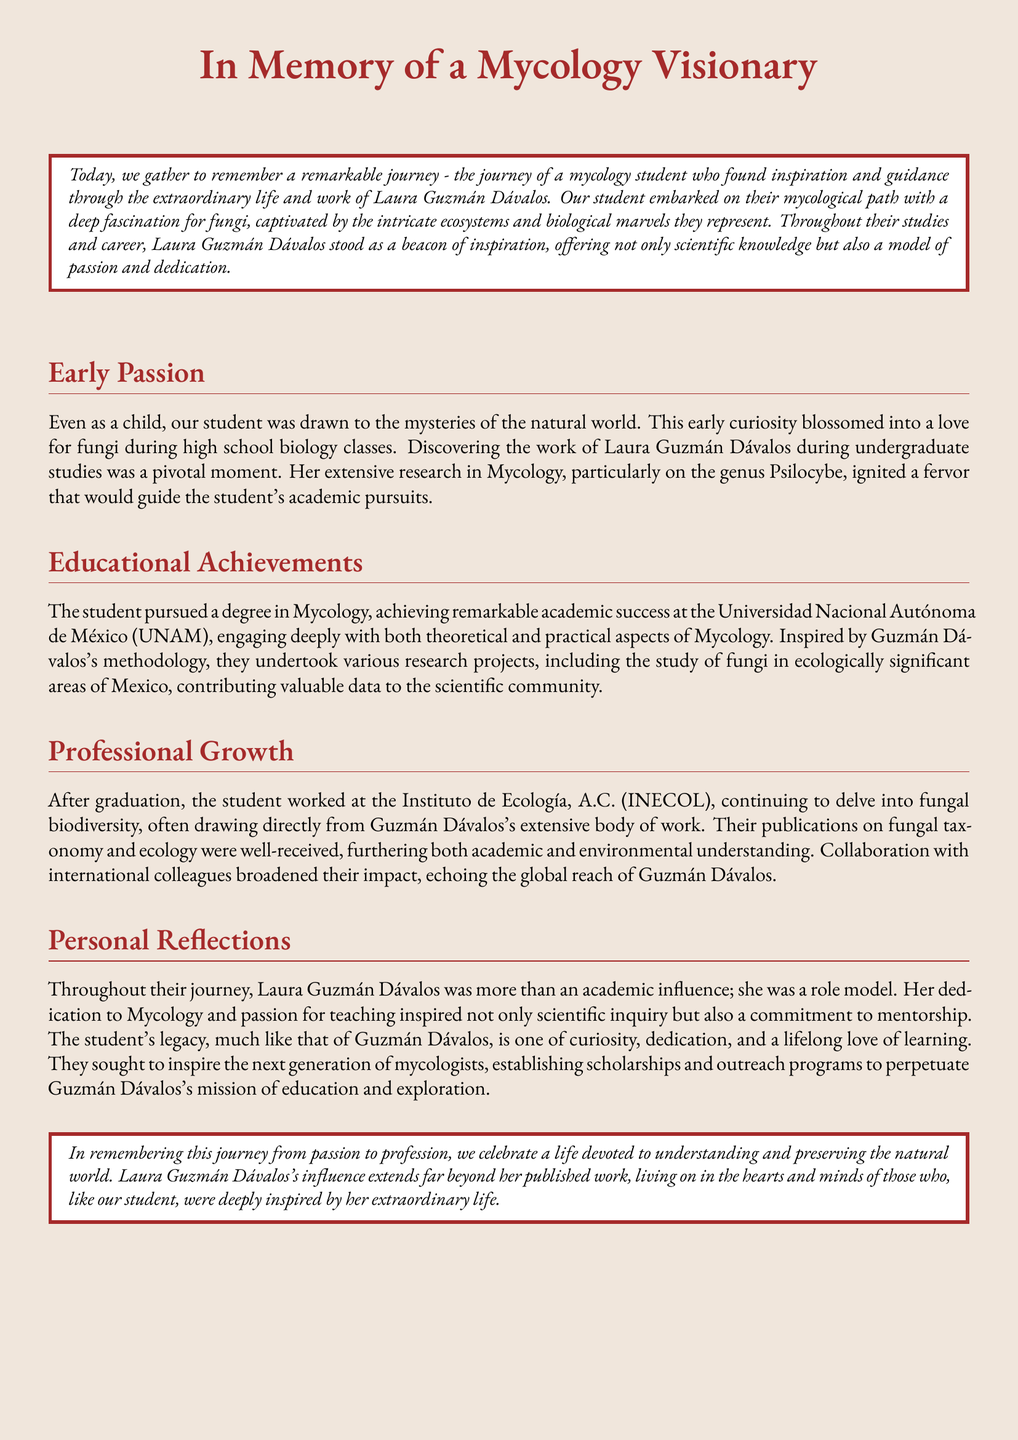What inspired the student to pursue Mycology? The student's inspiration came from discovering the work of Laura Guzmán Dávalos during undergraduate studies.
Answer: Laura Guzmán Dávalos Where did the student achieve their degree? The document states that the student pursued their degree at a specific university.
Answer: Universidad Nacional Autónoma de México (UNAM) What was a significant research area for Laura Guzmán Dávalos? The document highlights the specific research focus that ignited the student's passion for Mycology.
Answer: The genus Psilocybe What type of programs did the student establish? The student created initiatives to support future Mycologists, as mentioned in their efforts inspired by Guzmán Dávalos.
Answer: Scholarships and outreach programs Which institution did the student work for after graduation? The document specifies the organization where the student continued their research in fungal biodiversity.
Answer: Instituto de Ecología, A.C. (INECOL) What quality of Laura Guzmán Dávalos influenced the student? The document describes how Laura Guzmán Dávalos impacted the student not only academically but also personally.
Answer: Role model What is the overarching theme of the eulogy? The central message is summarized in the concluding statement regarding the student's journey and its significance.
Answer: Understanding and preserving the natural world In what year did the student begin their academic pursuit? The document does not state a specific year but refers to the beginning of their journey.
Answer: Not specified 